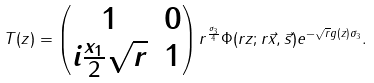Convert formula to latex. <formula><loc_0><loc_0><loc_500><loc_500>T ( z ) = \begin{pmatrix} 1 & 0 \\ i \frac { x _ { 1 } } { 2 } \sqrt { r } & 1 \end{pmatrix} r ^ { \frac { \sigma _ { 3 } } { 4 } } \Phi ( r z ; r \vec { x } , \vec { s } ) e ^ { - \sqrt { r } g ( z ) \sigma _ { 3 } } .</formula> 